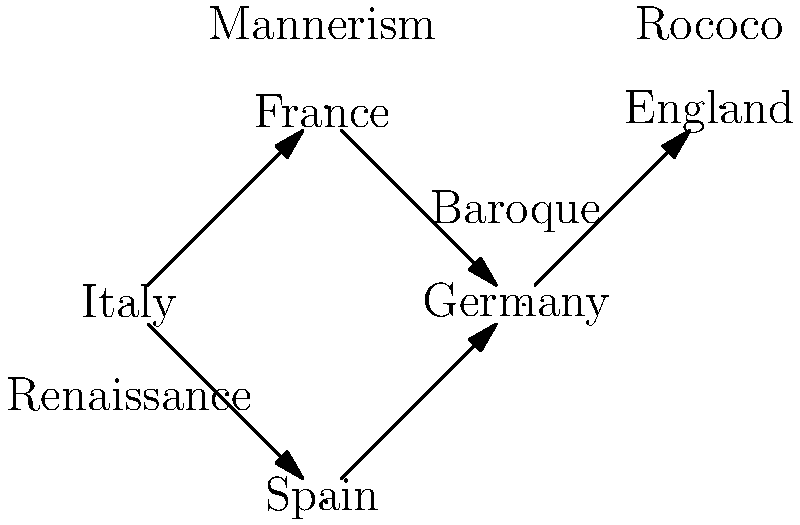Based on the flow diagram representing the spread of cultural influences across Europe during the Renaissance, which country appears to have been the primary source of artistic influence, and how did this influence progress through other European regions? To answer this question, we need to analyze the flow diagram step-by-step:

1. Observe the nodes: The diagram shows five nodes representing different European countries: Italy, France, Germany, Spain, and England.

2. Identify the starting point: Italy is positioned at the bottom left of the diagram, with arrows originating from it, suggesting it is the primary source of influence.

3. Trace the flow:
   a. Italy has arrows pointing to both France and Spain, indicating direct influence on these countries.
   b. France has an arrow pointing to Germany, showing that Italian influence reached Germany via France.
   c. Germany has an arrow pointing to England, suggesting that the influence continued to spread northward.

4. Analyze the artistic styles:
   a. Italy is labeled with "Renaissance," indicating it as the origin of this artistic movement.
   b. France is associated with "Mannerism," a style that developed from the Late Renaissance.
   c. Germany is linked to "Baroque," which succeeded Mannerism.
   d. England is connected to "Rococo," a style that followed Baroque.

5. Interpret the progression:
   The diagram shows a chronological and geographical progression of artistic styles, starting with the Renaissance in Italy and moving through subsequent styles as the influence spread northward across Europe.

Based on this analysis, we can conclude that Italy was the primary source of artistic influence during the Renaissance, and this influence spread first to France and Spain, then to Germany, and finally to England, evolving into different artistic styles along the way.
Answer: Italy; Renaissance → Mannerism → Baroque → Rococo, spreading from South to North. 